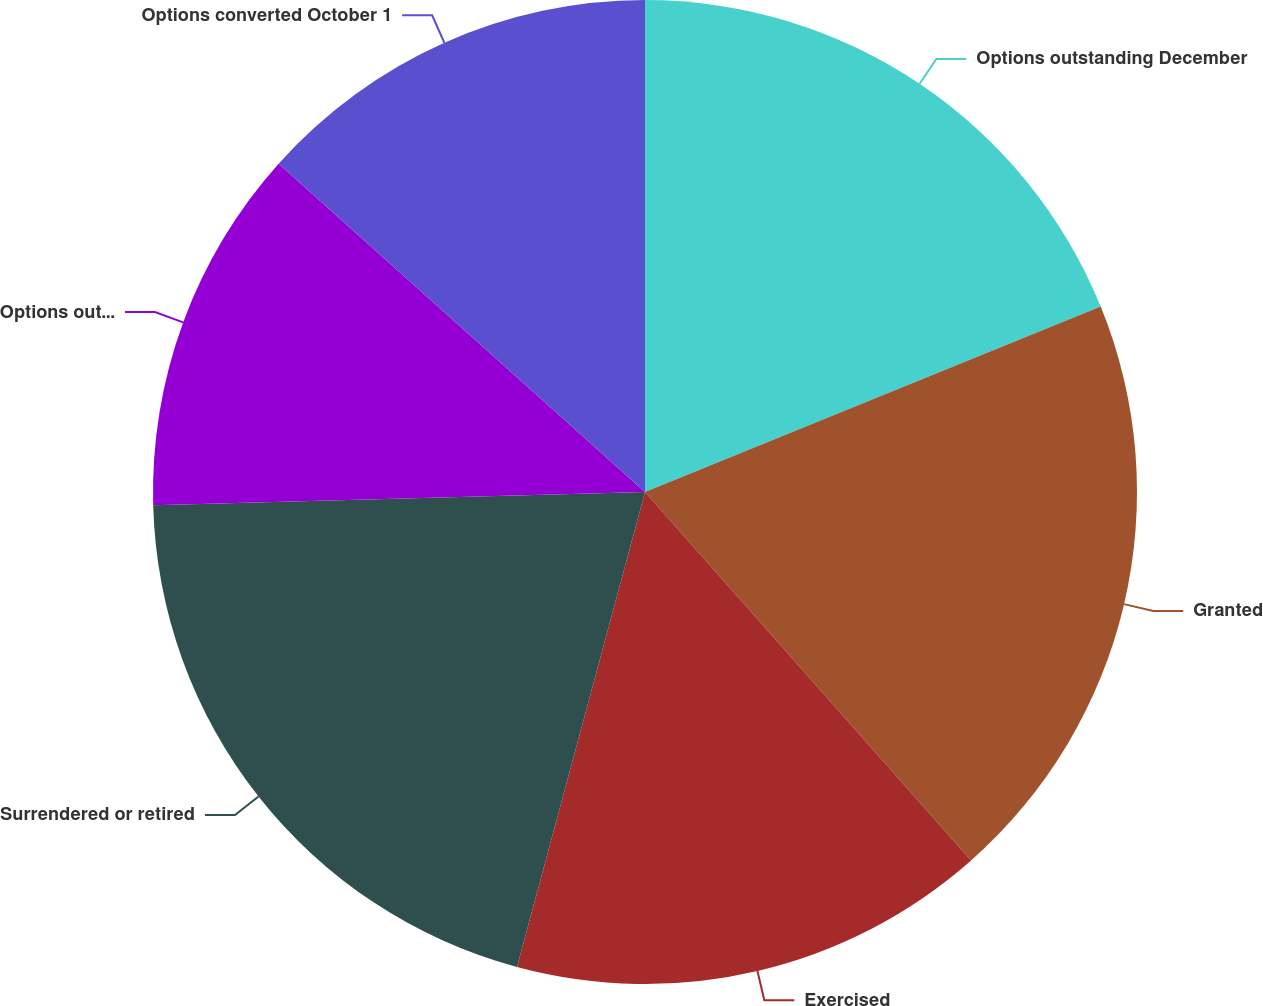<chart> <loc_0><loc_0><loc_500><loc_500><pie_chart><fcel>Options outstanding December<fcel>Granted<fcel>Exercised<fcel>Surrendered or retired<fcel>Options outstanding September<fcel>Options converted October 1<nl><fcel>18.85%<fcel>19.62%<fcel>15.72%<fcel>20.38%<fcel>12.06%<fcel>13.37%<nl></chart> 